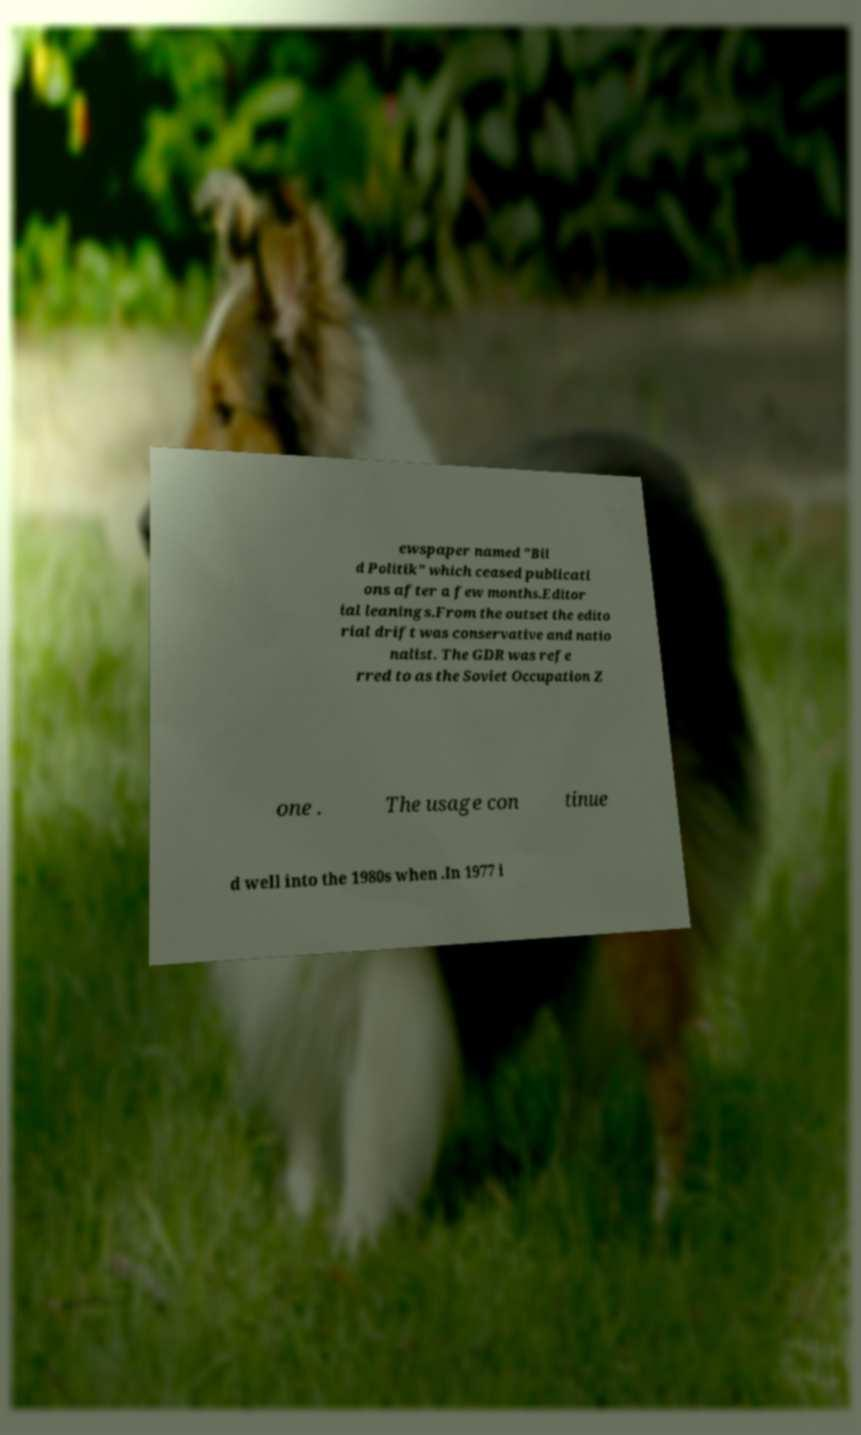What messages or text are displayed in this image? I need them in a readable, typed format. ewspaper named "Bil d Politik" which ceased publicati ons after a few months.Editor ial leanings.From the outset the edito rial drift was conservative and natio nalist. The GDR was refe rred to as the Soviet Occupation Z one . The usage con tinue d well into the 1980s when .In 1977 i 